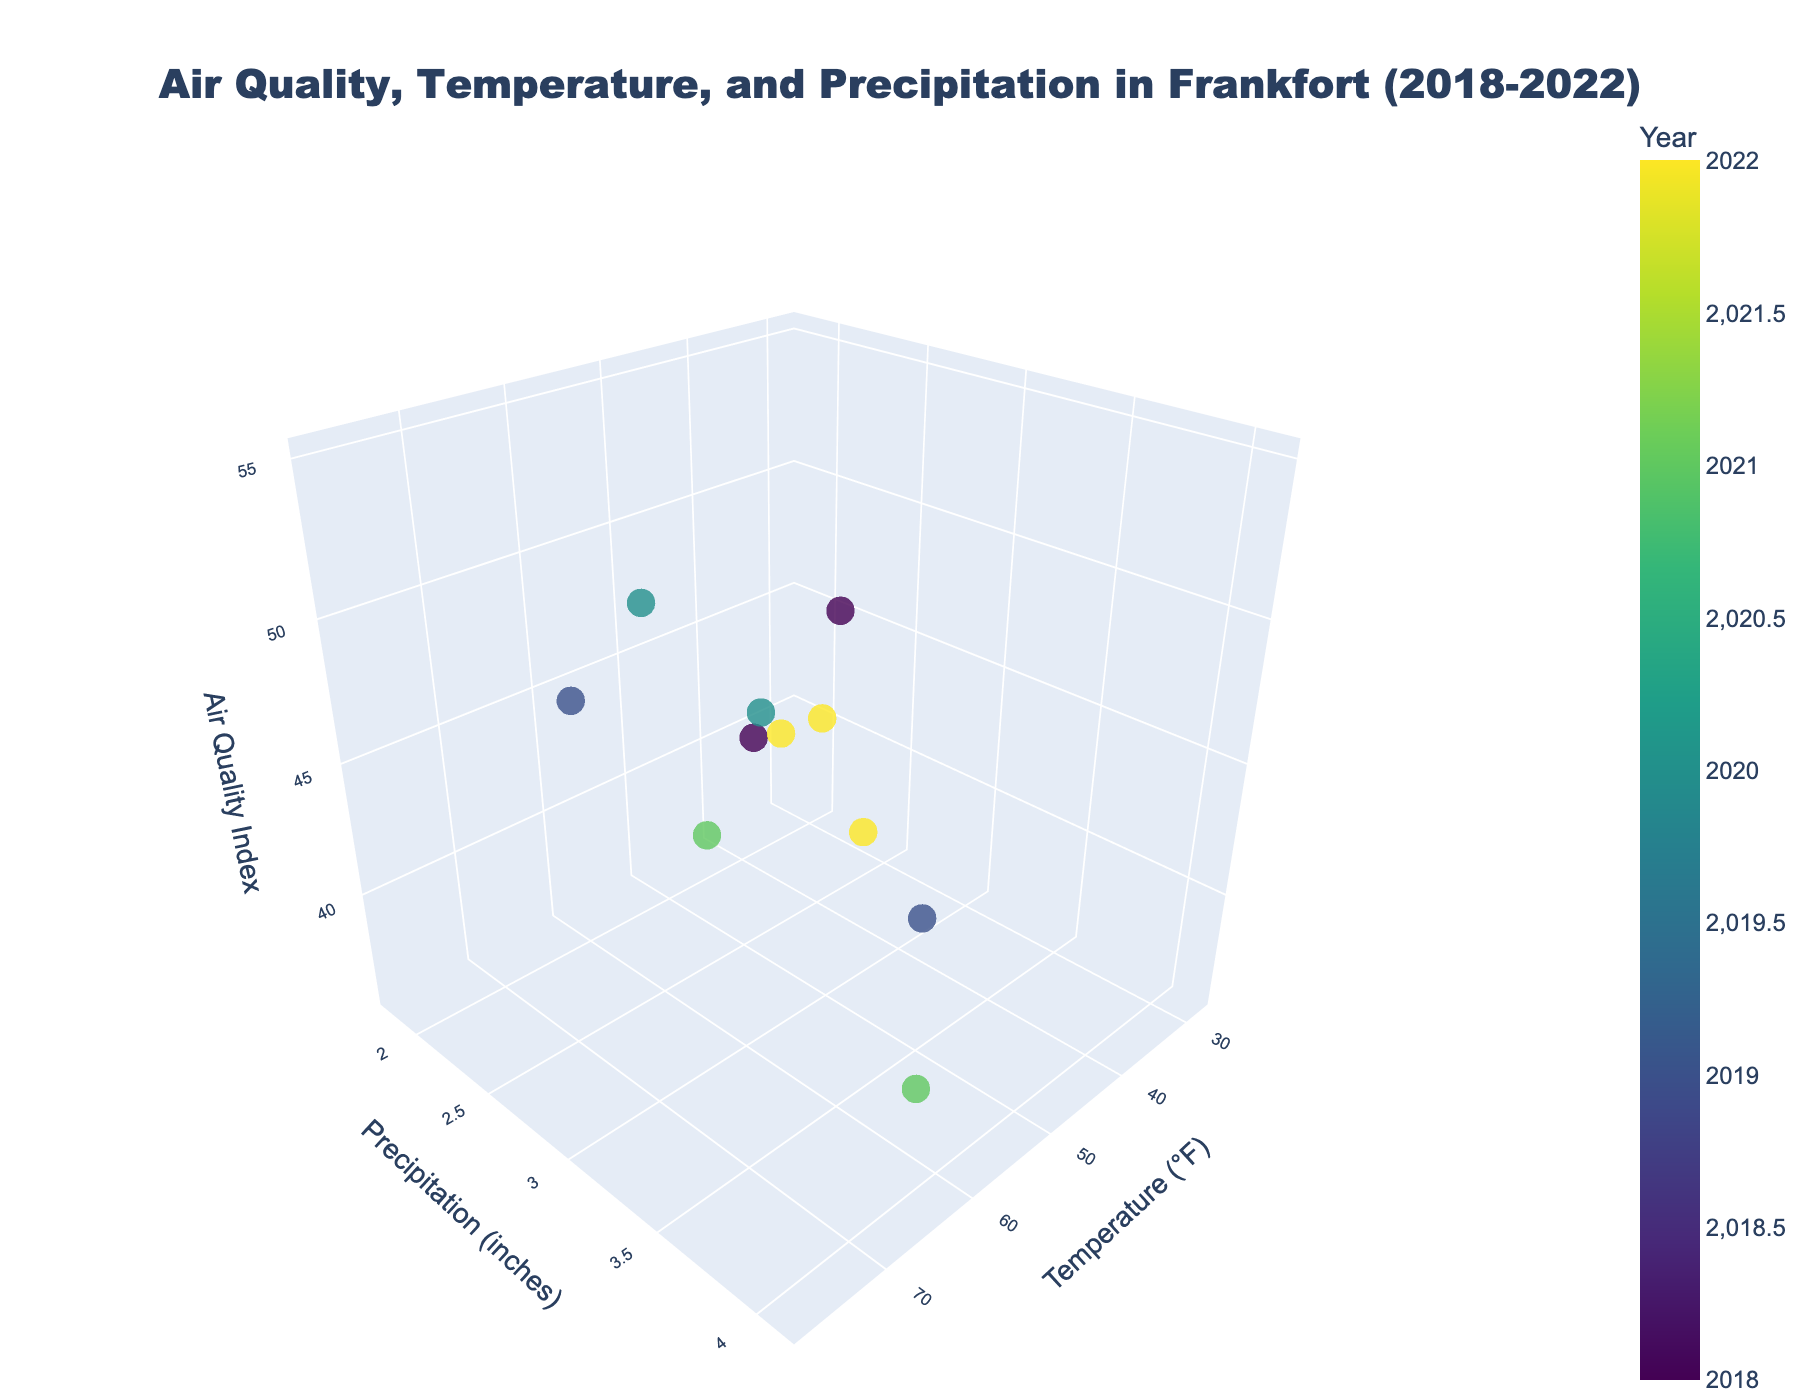What is the title of the 3D plot? The title is shown at the top of the figure. It is "Air Quality, Temperature, and Precipitation in Frankfort (2018-2022)."
Answer: Air Quality, Temperature, and Precipitation in Frankfort (2018-2022) What is the range of temperatures depicted in the plot? The x-axis represents temperature in °F, ranging from a minimum of around 28°F to a maximum of around 78°F.
Answer: 28°F to 78°F Which year has the highest Air Quality Index value, and what is that value? The color bar indicates the year, and the highest Air Quality Index value point is identified at 55 in 2020.
Answer: 2020, 55 What is the average Air Quality Index for data points with precipitation levels greater than 3 inches? Identify the data points with precipitation levels greater than 3 inches and average their Air Quality Index values. (45+52+38+55+36+50)/6 = 276/6 = 46
Answer: 46 Which month had the lowest temperature and what was the Air Quality Index for that month? Find the data point with the lowest temperature on the x-axis corresponding to 28°F in January 2018 and note the Air Quality Index of 45.
Answer: January 2018, 45 What is the Air Quality Index value for the data point with the highest precipitation level? Look for the highest precipitation value on the y-axis (4.1 inches) and corresponding Air Quality Index (50).
Answer: 50 Are there any data points where both the temperature is higher than 70°F and the Air Quality Index is higher than 50? If so, which years do they belong to? Identify data points with a temperature above 70°F and an Air Quality Index above 50, corresponding to the years 2020 (August) and 2022 (June).
Answer: 2020, 2022 Which has a lower Air Quality Index, March 2019 or October 2021, and what are the values? Compare the points representing March 2019 (38) and October 2021 (43) to determine the lower value.
Answer: March 2019, 38 Approximately how many data points are displayed in the 3D plot? Count the data points visually represented in the scatter plot; there are 11 data points (one for each of the months provided in the dataset).
Answer: 11 Is there any relationship between temperature and precipitation levels in the data? Based on the scatter plot's spread along the x-axis (temperature) and y-axis (precipitation), notice if data points cluster or distribute evenly. The relationship is generally varied, showing no clear correlation.
Answer: No clear correlation 